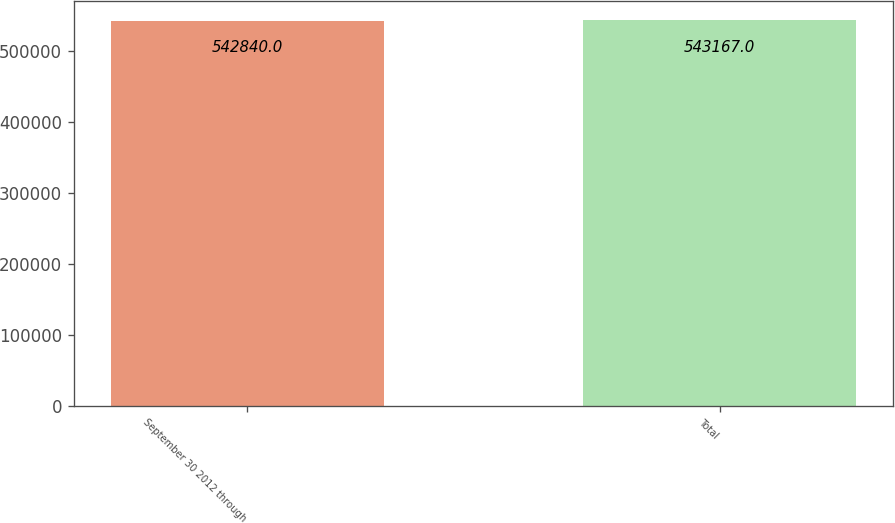Convert chart. <chart><loc_0><loc_0><loc_500><loc_500><bar_chart><fcel>September 30 2012 through<fcel>Total<nl><fcel>542840<fcel>543167<nl></chart> 